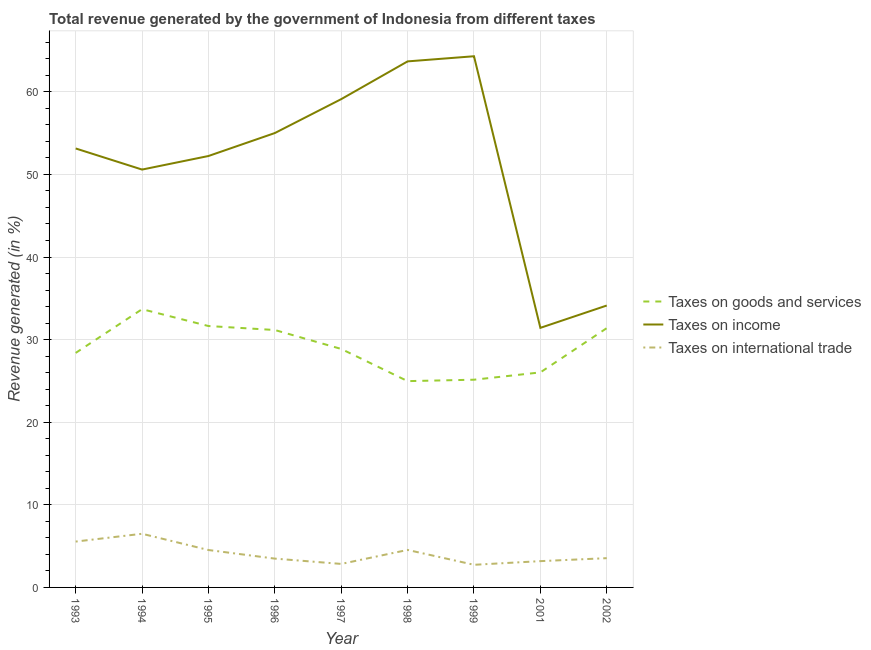How many different coloured lines are there?
Your response must be concise. 3. Does the line corresponding to percentage of revenue generated by taxes on goods and services intersect with the line corresponding to percentage of revenue generated by taxes on income?
Ensure brevity in your answer.  No. What is the percentage of revenue generated by tax on international trade in 1999?
Provide a succinct answer. 2.74. Across all years, what is the maximum percentage of revenue generated by taxes on goods and services?
Ensure brevity in your answer.  33.68. Across all years, what is the minimum percentage of revenue generated by taxes on income?
Make the answer very short. 31.42. In which year was the percentage of revenue generated by taxes on goods and services maximum?
Offer a very short reply. 1994. In which year was the percentage of revenue generated by taxes on income minimum?
Your answer should be very brief. 2001. What is the total percentage of revenue generated by taxes on goods and services in the graph?
Give a very brief answer. 261.29. What is the difference between the percentage of revenue generated by taxes on goods and services in 1993 and that in 1994?
Your answer should be very brief. -5.3. What is the difference between the percentage of revenue generated by taxes on income in 1995 and the percentage of revenue generated by tax on international trade in 2001?
Keep it short and to the point. 49.04. What is the average percentage of revenue generated by taxes on income per year?
Make the answer very short. 51.51. In the year 1995, what is the difference between the percentage of revenue generated by tax on international trade and percentage of revenue generated by taxes on income?
Ensure brevity in your answer.  -47.7. What is the ratio of the percentage of revenue generated by taxes on goods and services in 1997 to that in 1999?
Make the answer very short. 1.15. Is the percentage of revenue generated by tax on international trade in 1997 less than that in 1998?
Offer a terse response. Yes. Is the difference between the percentage of revenue generated by tax on international trade in 1993 and 1996 greater than the difference between the percentage of revenue generated by taxes on goods and services in 1993 and 1996?
Give a very brief answer. Yes. What is the difference between the highest and the second highest percentage of revenue generated by taxes on income?
Your answer should be compact. 0.62. What is the difference between the highest and the lowest percentage of revenue generated by tax on international trade?
Give a very brief answer. 3.76. In how many years, is the percentage of revenue generated by taxes on income greater than the average percentage of revenue generated by taxes on income taken over all years?
Provide a short and direct response. 6. Is the sum of the percentage of revenue generated by taxes on income in 1996 and 1998 greater than the maximum percentage of revenue generated by tax on international trade across all years?
Keep it short and to the point. Yes. Is it the case that in every year, the sum of the percentage of revenue generated by taxes on goods and services and percentage of revenue generated by taxes on income is greater than the percentage of revenue generated by tax on international trade?
Ensure brevity in your answer.  Yes. Is the percentage of revenue generated by tax on international trade strictly greater than the percentage of revenue generated by taxes on goods and services over the years?
Your answer should be compact. No. Is the percentage of revenue generated by taxes on income strictly less than the percentage of revenue generated by tax on international trade over the years?
Offer a very short reply. No. How many lines are there?
Your response must be concise. 3. What is the difference between two consecutive major ticks on the Y-axis?
Provide a short and direct response. 10. Are the values on the major ticks of Y-axis written in scientific E-notation?
Offer a very short reply. No. Does the graph contain grids?
Offer a terse response. Yes. How many legend labels are there?
Offer a terse response. 3. What is the title of the graph?
Your answer should be compact. Total revenue generated by the government of Indonesia from different taxes. Does "Self-employed" appear as one of the legend labels in the graph?
Keep it short and to the point. No. What is the label or title of the X-axis?
Make the answer very short. Year. What is the label or title of the Y-axis?
Provide a succinct answer. Revenue generated (in %). What is the Revenue generated (in %) of Taxes on goods and services in 1993?
Your answer should be compact. 28.39. What is the Revenue generated (in %) of Taxes on income in 1993?
Keep it short and to the point. 53.14. What is the Revenue generated (in %) of Taxes on international trade in 1993?
Your answer should be compact. 5.55. What is the Revenue generated (in %) of Taxes on goods and services in 1994?
Your answer should be very brief. 33.68. What is the Revenue generated (in %) in Taxes on income in 1994?
Keep it short and to the point. 50.58. What is the Revenue generated (in %) of Taxes on international trade in 1994?
Your answer should be compact. 6.5. What is the Revenue generated (in %) in Taxes on goods and services in 1995?
Give a very brief answer. 31.64. What is the Revenue generated (in %) of Taxes on income in 1995?
Keep it short and to the point. 52.23. What is the Revenue generated (in %) in Taxes on international trade in 1995?
Give a very brief answer. 4.53. What is the Revenue generated (in %) of Taxes on goods and services in 1996?
Keep it short and to the point. 31.16. What is the Revenue generated (in %) of Taxes on income in 1996?
Offer a very short reply. 55.01. What is the Revenue generated (in %) in Taxes on international trade in 1996?
Your response must be concise. 3.49. What is the Revenue generated (in %) of Taxes on goods and services in 1997?
Give a very brief answer. 28.87. What is the Revenue generated (in %) in Taxes on income in 1997?
Give a very brief answer. 59.11. What is the Revenue generated (in %) in Taxes on international trade in 1997?
Your answer should be very brief. 2.85. What is the Revenue generated (in %) of Taxes on goods and services in 1998?
Your response must be concise. 24.97. What is the Revenue generated (in %) in Taxes on income in 1998?
Your response must be concise. 63.68. What is the Revenue generated (in %) in Taxes on international trade in 1998?
Your answer should be compact. 4.54. What is the Revenue generated (in %) in Taxes on goods and services in 1999?
Provide a short and direct response. 25.14. What is the Revenue generated (in %) of Taxes on income in 1999?
Offer a very short reply. 64.3. What is the Revenue generated (in %) in Taxes on international trade in 1999?
Offer a terse response. 2.74. What is the Revenue generated (in %) in Taxes on goods and services in 2001?
Keep it short and to the point. 26.03. What is the Revenue generated (in %) of Taxes on income in 2001?
Make the answer very short. 31.42. What is the Revenue generated (in %) of Taxes on international trade in 2001?
Your answer should be very brief. 3.18. What is the Revenue generated (in %) of Taxes on goods and services in 2002?
Ensure brevity in your answer.  31.39. What is the Revenue generated (in %) of Taxes on income in 2002?
Provide a short and direct response. 34.13. What is the Revenue generated (in %) of Taxes on international trade in 2002?
Provide a succinct answer. 3.54. Across all years, what is the maximum Revenue generated (in %) of Taxes on goods and services?
Your answer should be compact. 33.68. Across all years, what is the maximum Revenue generated (in %) in Taxes on income?
Provide a short and direct response. 64.3. Across all years, what is the maximum Revenue generated (in %) in Taxes on international trade?
Provide a short and direct response. 6.5. Across all years, what is the minimum Revenue generated (in %) of Taxes on goods and services?
Offer a very short reply. 24.97. Across all years, what is the minimum Revenue generated (in %) in Taxes on income?
Provide a short and direct response. 31.42. Across all years, what is the minimum Revenue generated (in %) in Taxes on international trade?
Ensure brevity in your answer.  2.74. What is the total Revenue generated (in %) of Taxes on goods and services in the graph?
Give a very brief answer. 261.29. What is the total Revenue generated (in %) of Taxes on income in the graph?
Provide a succinct answer. 463.6. What is the total Revenue generated (in %) of Taxes on international trade in the graph?
Offer a terse response. 36.91. What is the difference between the Revenue generated (in %) of Taxes on goods and services in 1993 and that in 1994?
Offer a terse response. -5.29. What is the difference between the Revenue generated (in %) in Taxes on income in 1993 and that in 1994?
Offer a terse response. 2.55. What is the difference between the Revenue generated (in %) in Taxes on international trade in 1993 and that in 1994?
Keep it short and to the point. -0.94. What is the difference between the Revenue generated (in %) of Taxes on goods and services in 1993 and that in 1995?
Your answer should be very brief. -3.25. What is the difference between the Revenue generated (in %) in Taxes on income in 1993 and that in 1995?
Your answer should be compact. 0.91. What is the difference between the Revenue generated (in %) in Taxes on international trade in 1993 and that in 1995?
Your answer should be very brief. 1.02. What is the difference between the Revenue generated (in %) in Taxes on goods and services in 1993 and that in 1996?
Your answer should be compact. -2.77. What is the difference between the Revenue generated (in %) of Taxes on income in 1993 and that in 1996?
Offer a terse response. -1.87. What is the difference between the Revenue generated (in %) of Taxes on international trade in 1993 and that in 1996?
Give a very brief answer. 2.06. What is the difference between the Revenue generated (in %) of Taxes on goods and services in 1993 and that in 1997?
Give a very brief answer. -0.48. What is the difference between the Revenue generated (in %) in Taxes on income in 1993 and that in 1997?
Ensure brevity in your answer.  -5.97. What is the difference between the Revenue generated (in %) of Taxes on international trade in 1993 and that in 1997?
Provide a succinct answer. 2.7. What is the difference between the Revenue generated (in %) of Taxes on goods and services in 1993 and that in 1998?
Make the answer very short. 3.42. What is the difference between the Revenue generated (in %) of Taxes on income in 1993 and that in 1998?
Ensure brevity in your answer.  -10.54. What is the difference between the Revenue generated (in %) of Taxes on international trade in 1993 and that in 1998?
Keep it short and to the point. 1.01. What is the difference between the Revenue generated (in %) of Taxes on goods and services in 1993 and that in 1999?
Offer a very short reply. 3.24. What is the difference between the Revenue generated (in %) of Taxes on income in 1993 and that in 1999?
Make the answer very short. -11.16. What is the difference between the Revenue generated (in %) of Taxes on international trade in 1993 and that in 1999?
Your answer should be compact. 2.81. What is the difference between the Revenue generated (in %) of Taxes on goods and services in 1993 and that in 2001?
Offer a terse response. 2.36. What is the difference between the Revenue generated (in %) in Taxes on income in 1993 and that in 2001?
Give a very brief answer. 21.72. What is the difference between the Revenue generated (in %) of Taxes on international trade in 1993 and that in 2001?
Give a very brief answer. 2.37. What is the difference between the Revenue generated (in %) in Taxes on goods and services in 1993 and that in 2002?
Your answer should be very brief. -3. What is the difference between the Revenue generated (in %) in Taxes on income in 1993 and that in 2002?
Your response must be concise. 19.01. What is the difference between the Revenue generated (in %) in Taxes on international trade in 1993 and that in 2002?
Your answer should be very brief. 2.01. What is the difference between the Revenue generated (in %) of Taxes on goods and services in 1994 and that in 1995?
Ensure brevity in your answer.  2.04. What is the difference between the Revenue generated (in %) in Taxes on income in 1994 and that in 1995?
Your answer should be compact. -1.64. What is the difference between the Revenue generated (in %) in Taxes on international trade in 1994 and that in 1995?
Ensure brevity in your answer.  1.97. What is the difference between the Revenue generated (in %) of Taxes on goods and services in 1994 and that in 1996?
Ensure brevity in your answer.  2.52. What is the difference between the Revenue generated (in %) in Taxes on income in 1994 and that in 1996?
Your answer should be very brief. -4.42. What is the difference between the Revenue generated (in %) of Taxes on international trade in 1994 and that in 1996?
Your answer should be compact. 3.01. What is the difference between the Revenue generated (in %) in Taxes on goods and services in 1994 and that in 1997?
Offer a terse response. 4.81. What is the difference between the Revenue generated (in %) of Taxes on income in 1994 and that in 1997?
Keep it short and to the point. -8.53. What is the difference between the Revenue generated (in %) of Taxes on international trade in 1994 and that in 1997?
Make the answer very short. 3.65. What is the difference between the Revenue generated (in %) of Taxes on goods and services in 1994 and that in 1998?
Your answer should be very brief. 8.71. What is the difference between the Revenue generated (in %) of Taxes on income in 1994 and that in 1998?
Provide a succinct answer. -13.1. What is the difference between the Revenue generated (in %) in Taxes on international trade in 1994 and that in 1998?
Offer a terse response. 1.96. What is the difference between the Revenue generated (in %) in Taxes on goods and services in 1994 and that in 1999?
Make the answer very short. 8.54. What is the difference between the Revenue generated (in %) of Taxes on income in 1994 and that in 1999?
Offer a very short reply. -13.72. What is the difference between the Revenue generated (in %) in Taxes on international trade in 1994 and that in 1999?
Your answer should be very brief. 3.76. What is the difference between the Revenue generated (in %) of Taxes on goods and services in 1994 and that in 2001?
Offer a very short reply. 7.65. What is the difference between the Revenue generated (in %) in Taxes on income in 1994 and that in 2001?
Give a very brief answer. 19.16. What is the difference between the Revenue generated (in %) of Taxes on international trade in 1994 and that in 2001?
Make the answer very short. 3.31. What is the difference between the Revenue generated (in %) in Taxes on goods and services in 1994 and that in 2002?
Offer a very short reply. 2.29. What is the difference between the Revenue generated (in %) of Taxes on income in 1994 and that in 2002?
Your response must be concise. 16.46. What is the difference between the Revenue generated (in %) in Taxes on international trade in 1994 and that in 2002?
Your answer should be very brief. 2.95. What is the difference between the Revenue generated (in %) of Taxes on goods and services in 1995 and that in 1996?
Provide a succinct answer. 0.48. What is the difference between the Revenue generated (in %) of Taxes on income in 1995 and that in 1996?
Your answer should be very brief. -2.78. What is the difference between the Revenue generated (in %) of Taxes on international trade in 1995 and that in 1996?
Offer a terse response. 1.04. What is the difference between the Revenue generated (in %) of Taxes on goods and services in 1995 and that in 1997?
Make the answer very short. 2.77. What is the difference between the Revenue generated (in %) in Taxes on income in 1995 and that in 1997?
Your response must be concise. -6.89. What is the difference between the Revenue generated (in %) of Taxes on international trade in 1995 and that in 1997?
Ensure brevity in your answer.  1.68. What is the difference between the Revenue generated (in %) in Taxes on goods and services in 1995 and that in 1998?
Keep it short and to the point. 6.67. What is the difference between the Revenue generated (in %) of Taxes on income in 1995 and that in 1998?
Your answer should be very brief. -11.46. What is the difference between the Revenue generated (in %) in Taxes on international trade in 1995 and that in 1998?
Provide a succinct answer. -0.01. What is the difference between the Revenue generated (in %) of Taxes on goods and services in 1995 and that in 1999?
Make the answer very short. 6.5. What is the difference between the Revenue generated (in %) of Taxes on income in 1995 and that in 1999?
Make the answer very short. -12.08. What is the difference between the Revenue generated (in %) in Taxes on international trade in 1995 and that in 1999?
Keep it short and to the point. 1.79. What is the difference between the Revenue generated (in %) in Taxes on goods and services in 1995 and that in 2001?
Provide a short and direct response. 5.61. What is the difference between the Revenue generated (in %) of Taxes on income in 1995 and that in 2001?
Your answer should be very brief. 20.8. What is the difference between the Revenue generated (in %) of Taxes on international trade in 1995 and that in 2001?
Your answer should be compact. 1.35. What is the difference between the Revenue generated (in %) of Taxes on goods and services in 1995 and that in 2002?
Your response must be concise. 0.25. What is the difference between the Revenue generated (in %) of Taxes on income in 1995 and that in 2002?
Give a very brief answer. 18.1. What is the difference between the Revenue generated (in %) in Taxes on international trade in 1995 and that in 2002?
Your answer should be very brief. 0.99. What is the difference between the Revenue generated (in %) of Taxes on goods and services in 1996 and that in 1997?
Offer a terse response. 2.29. What is the difference between the Revenue generated (in %) in Taxes on income in 1996 and that in 1997?
Offer a terse response. -4.1. What is the difference between the Revenue generated (in %) in Taxes on international trade in 1996 and that in 1997?
Offer a very short reply. 0.64. What is the difference between the Revenue generated (in %) of Taxes on goods and services in 1996 and that in 1998?
Your answer should be compact. 6.19. What is the difference between the Revenue generated (in %) in Taxes on income in 1996 and that in 1998?
Ensure brevity in your answer.  -8.67. What is the difference between the Revenue generated (in %) of Taxes on international trade in 1996 and that in 1998?
Offer a terse response. -1.05. What is the difference between the Revenue generated (in %) in Taxes on goods and services in 1996 and that in 1999?
Provide a succinct answer. 6.02. What is the difference between the Revenue generated (in %) in Taxes on income in 1996 and that in 1999?
Provide a short and direct response. -9.3. What is the difference between the Revenue generated (in %) of Taxes on international trade in 1996 and that in 1999?
Offer a very short reply. 0.75. What is the difference between the Revenue generated (in %) in Taxes on goods and services in 1996 and that in 2001?
Your answer should be compact. 5.13. What is the difference between the Revenue generated (in %) of Taxes on income in 1996 and that in 2001?
Provide a succinct answer. 23.58. What is the difference between the Revenue generated (in %) in Taxes on international trade in 1996 and that in 2001?
Keep it short and to the point. 0.31. What is the difference between the Revenue generated (in %) of Taxes on goods and services in 1996 and that in 2002?
Provide a succinct answer. -0.23. What is the difference between the Revenue generated (in %) in Taxes on income in 1996 and that in 2002?
Provide a succinct answer. 20.88. What is the difference between the Revenue generated (in %) of Taxes on international trade in 1996 and that in 2002?
Give a very brief answer. -0.05. What is the difference between the Revenue generated (in %) of Taxes on goods and services in 1997 and that in 1998?
Offer a very short reply. 3.9. What is the difference between the Revenue generated (in %) of Taxes on income in 1997 and that in 1998?
Keep it short and to the point. -4.57. What is the difference between the Revenue generated (in %) of Taxes on international trade in 1997 and that in 1998?
Keep it short and to the point. -1.69. What is the difference between the Revenue generated (in %) of Taxes on goods and services in 1997 and that in 1999?
Your response must be concise. 3.72. What is the difference between the Revenue generated (in %) of Taxes on income in 1997 and that in 1999?
Your answer should be very brief. -5.19. What is the difference between the Revenue generated (in %) in Taxes on international trade in 1997 and that in 1999?
Keep it short and to the point. 0.11. What is the difference between the Revenue generated (in %) in Taxes on goods and services in 1997 and that in 2001?
Provide a short and direct response. 2.84. What is the difference between the Revenue generated (in %) of Taxes on income in 1997 and that in 2001?
Provide a short and direct response. 27.69. What is the difference between the Revenue generated (in %) of Taxes on international trade in 1997 and that in 2001?
Offer a very short reply. -0.34. What is the difference between the Revenue generated (in %) in Taxes on goods and services in 1997 and that in 2002?
Provide a short and direct response. -2.52. What is the difference between the Revenue generated (in %) in Taxes on income in 1997 and that in 2002?
Offer a terse response. 24.98. What is the difference between the Revenue generated (in %) in Taxes on international trade in 1997 and that in 2002?
Your answer should be compact. -0.7. What is the difference between the Revenue generated (in %) of Taxes on goods and services in 1998 and that in 1999?
Give a very brief answer. -0.17. What is the difference between the Revenue generated (in %) in Taxes on income in 1998 and that in 1999?
Your answer should be compact. -0.62. What is the difference between the Revenue generated (in %) in Taxes on international trade in 1998 and that in 1999?
Provide a short and direct response. 1.8. What is the difference between the Revenue generated (in %) of Taxes on goods and services in 1998 and that in 2001?
Your answer should be very brief. -1.06. What is the difference between the Revenue generated (in %) of Taxes on income in 1998 and that in 2001?
Ensure brevity in your answer.  32.26. What is the difference between the Revenue generated (in %) in Taxes on international trade in 1998 and that in 2001?
Your answer should be very brief. 1.36. What is the difference between the Revenue generated (in %) of Taxes on goods and services in 1998 and that in 2002?
Give a very brief answer. -6.42. What is the difference between the Revenue generated (in %) of Taxes on income in 1998 and that in 2002?
Your answer should be very brief. 29.55. What is the difference between the Revenue generated (in %) in Taxes on international trade in 1998 and that in 2002?
Provide a short and direct response. 1. What is the difference between the Revenue generated (in %) of Taxes on goods and services in 1999 and that in 2001?
Provide a succinct answer. -0.89. What is the difference between the Revenue generated (in %) in Taxes on income in 1999 and that in 2001?
Ensure brevity in your answer.  32.88. What is the difference between the Revenue generated (in %) in Taxes on international trade in 1999 and that in 2001?
Provide a short and direct response. -0.44. What is the difference between the Revenue generated (in %) of Taxes on goods and services in 1999 and that in 2002?
Keep it short and to the point. -6.25. What is the difference between the Revenue generated (in %) in Taxes on income in 1999 and that in 2002?
Make the answer very short. 30.18. What is the difference between the Revenue generated (in %) in Taxes on international trade in 1999 and that in 2002?
Offer a terse response. -0.8. What is the difference between the Revenue generated (in %) of Taxes on goods and services in 2001 and that in 2002?
Ensure brevity in your answer.  -5.36. What is the difference between the Revenue generated (in %) in Taxes on income in 2001 and that in 2002?
Give a very brief answer. -2.7. What is the difference between the Revenue generated (in %) of Taxes on international trade in 2001 and that in 2002?
Your answer should be very brief. -0.36. What is the difference between the Revenue generated (in %) in Taxes on goods and services in 1993 and the Revenue generated (in %) in Taxes on income in 1994?
Your answer should be compact. -22.19. What is the difference between the Revenue generated (in %) in Taxes on goods and services in 1993 and the Revenue generated (in %) in Taxes on international trade in 1994?
Provide a short and direct response. 21.89. What is the difference between the Revenue generated (in %) of Taxes on income in 1993 and the Revenue generated (in %) of Taxes on international trade in 1994?
Your response must be concise. 46.64. What is the difference between the Revenue generated (in %) of Taxes on goods and services in 1993 and the Revenue generated (in %) of Taxes on income in 1995?
Your response must be concise. -23.84. What is the difference between the Revenue generated (in %) of Taxes on goods and services in 1993 and the Revenue generated (in %) of Taxes on international trade in 1995?
Make the answer very short. 23.86. What is the difference between the Revenue generated (in %) in Taxes on income in 1993 and the Revenue generated (in %) in Taxes on international trade in 1995?
Ensure brevity in your answer.  48.61. What is the difference between the Revenue generated (in %) of Taxes on goods and services in 1993 and the Revenue generated (in %) of Taxes on income in 1996?
Your response must be concise. -26.62. What is the difference between the Revenue generated (in %) in Taxes on goods and services in 1993 and the Revenue generated (in %) in Taxes on international trade in 1996?
Offer a very short reply. 24.9. What is the difference between the Revenue generated (in %) of Taxes on income in 1993 and the Revenue generated (in %) of Taxes on international trade in 1996?
Make the answer very short. 49.65. What is the difference between the Revenue generated (in %) in Taxes on goods and services in 1993 and the Revenue generated (in %) in Taxes on income in 1997?
Your answer should be very brief. -30.72. What is the difference between the Revenue generated (in %) of Taxes on goods and services in 1993 and the Revenue generated (in %) of Taxes on international trade in 1997?
Ensure brevity in your answer.  25.54. What is the difference between the Revenue generated (in %) of Taxes on income in 1993 and the Revenue generated (in %) of Taxes on international trade in 1997?
Your response must be concise. 50.29. What is the difference between the Revenue generated (in %) of Taxes on goods and services in 1993 and the Revenue generated (in %) of Taxes on income in 1998?
Provide a short and direct response. -35.29. What is the difference between the Revenue generated (in %) in Taxes on goods and services in 1993 and the Revenue generated (in %) in Taxes on international trade in 1998?
Your answer should be compact. 23.85. What is the difference between the Revenue generated (in %) in Taxes on income in 1993 and the Revenue generated (in %) in Taxes on international trade in 1998?
Your answer should be compact. 48.6. What is the difference between the Revenue generated (in %) of Taxes on goods and services in 1993 and the Revenue generated (in %) of Taxes on income in 1999?
Offer a very short reply. -35.91. What is the difference between the Revenue generated (in %) of Taxes on goods and services in 1993 and the Revenue generated (in %) of Taxes on international trade in 1999?
Provide a succinct answer. 25.65. What is the difference between the Revenue generated (in %) in Taxes on income in 1993 and the Revenue generated (in %) in Taxes on international trade in 1999?
Offer a terse response. 50.4. What is the difference between the Revenue generated (in %) of Taxes on goods and services in 1993 and the Revenue generated (in %) of Taxes on income in 2001?
Your answer should be very brief. -3.03. What is the difference between the Revenue generated (in %) in Taxes on goods and services in 1993 and the Revenue generated (in %) in Taxes on international trade in 2001?
Ensure brevity in your answer.  25.21. What is the difference between the Revenue generated (in %) in Taxes on income in 1993 and the Revenue generated (in %) in Taxes on international trade in 2001?
Keep it short and to the point. 49.96. What is the difference between the Revenue generated (in %) in Taxes on goods and services in 1993 and the Revenue generated (in %) in Taxes on income in 2002?
Make the answer very short. -5.74. What is the difference between the Revenue generated (in %) in Taxes on goods and services in 1993 and the Revenue generated (in %) in Taxes on international trade in 2002?
Provide a short and direct response. 24.85. What is the difference between the Revenue generated (in %) of Taxes on income in 1993 and the Revenue generated (in %) of Taxes on international trade in 2002?
Your response must be concise. 49.6. What is the difference between the Revenue generated (in %) in Taxes on goods and services in 1994 and the Revenue generated (in %) in Taxes on income in 1995?
Your answer should be compact. -18.54. What is the difference between the Revenue generated (in %) of Taxes on goods and services in 1994 and the Revenue generated (in %) of Taxes on international trade in 1995?
Offer a terse response. 29.16. What is the difference between the Revenue generated (in %) in Taxes on income in 1994 and the Revenue generated (in %) in Taxes on international trade in 1995?
Your answer should be very brief. 46.06. What is the difference between the Revenue generated (in %) in Taxes on goods and services in 1994 and the Revenue generated (in %) in Taxes on income in 1996?
Provide a short and direct response. -21.32. What is the difference between the Revenue generated (in %) of Taxes on goods and services in 1994 and the Revenue generated (in %) of Taxes on international trade in 1996?
Offer a terse response. 30.2. What is the difference between the Revenue generated (in %) of Taxes on income in 1994 and the Revenue generated (in %) of Taxes on international trade in 1996?
Keep it short and to the point. 47.1. What is the difference between the Revenue generated (in %) in Taxes on goods and services in 1994 and the Revenue generated (in %) in Taxes on income in 1997?
Provide a short and direct response. -25.43. What is the difference between the Revenue generated (in %) in Taxes on goods and services in 1994 and the Revenue generated (in %) in Taxes on international trade in 1997?
Make the answer very short. 30.84. What is the difference between the Revenue generated (in %) of Taxes on income in 1994 and the Revenue generated (in %) of Taxes on international trade in 1997?
Give a very brief answer. 47.74. What is the difference between the Revenue generated (in %) of Taxes on goods and services in 1994 and the Revenue generated (in %) of Taxes on income in 1998?
Keep it short and to the point. -30. What is the difference between the Revenue generated (in %) in Taxes on goods and services in 1994 and the Revenue generated (in %) in Taxes on international trade in 1998?
Give a very brief answer. 29.15. What is the difference between the Revenue generated (in %) in Taxes on income in 1994 and the Revenue generated (in %) in Taxes on international trade in 1998?
Make the answer very short. 46.05. What is the difference between the Revenue generated (in %) of Taxes on goods and services in 1994 and the Revenue generated (in %) of Taxes on income in 1999?
Offer a very short reply. -30.62. What is the difference between the Revenue generated (in %) of Taxes on goods and services in 1994 and the Revenue generated (in %) of Taxes on international trade in 1999?
Give a very brief answer. 30.94. What is the difference between the Revenue generated (in %) in Taxes on income in 1994 and the Revenue generated (in %) in Taxes on international trade in 1999?
Ensure brevity in your answer.  47.84. What is the difference between the Revenue generated (in %) of Taxes on goods and services in 1994 and the Revenue generated (in %) of Taxes on income in 2001?
Keep it short and to the point. 2.26. What is the difference between the Revenue generated (in %) of Taxes on goods and services in 1994 and the Revenue generated (in %) of Taxes on international trade in 2001?
Your answer should be very brief. 30.5. What is the difference between the Revenue generated (in %) of Taxes on income in 1994 and the Revenue generated (in %) of Taxes on international trade in 2001?
Make the answer very short. 47.4. What is the difference between the Revenue generated (in %) in Taxes on goods and services in 1994 and the Revenue generated (in %) in Taxes on income in 2002?
Your response must be concise. -0.44. What is the difference between the Revenue generated (in %) in Taxes on goods and services in 1994 and the Revenue generated (in %) in Taxes on international trade in 2002?
Keep it short and to the point. 30.14. What is the difference between the Revenue generated (in %) of Taxes on income in 1994 and the Revenue generated (in %) of Taxes on international trade in 2002?
Provide a succinct answer. 47.04. What is the difference between the Revenue generated (in %) of Taxes on goods and services in 1995 and the Revenue generated (in %) of Taxes on income in 1996?
Your answer should be very brief. -23.36. What is the difference between the Revenue generated (in %) in Taxes on goods and services in 1995 and the Revenue generated (in %) in Taxes on international trade in 1996?
Make the answer very short. 28.16. What is the difference between the Revenue generated (in %) in Taxes on income in 1995 and the Revenue generated (in %) in Taxes on international trade in 1996?
Offer a very short reply. 48.74. What is the difference between the Revenue generated (in %) in Taxes on goods and services in 1995 and the Revenue generated (in %) in Taxes on income in 1997?
Make the answer very short. -27.47. What is the difference between the Revenue generated (in %) in Taxes on goods and services in 1995 and the Revenue generated (in %) in Taxes on international trade in 1997?
Give a very brief answer. 28.8. What is the difference between the Revenue generated (in %) of Taxes on income in 1995 and the Revenue generated (in %) of Taxes on international trade in 1997?
Ensure brevity in your answer.  49.38. What is the difference between the Revenue generated (in %) of Taxes on goods and services in 1995 and the Revenue generated (in %) of Taxes on income in 1998?
Your answer should be compact. -32.04. What is the difference between the Revenue generated (in %) in Taxes on goods and services in 1995 and the Revenue generated (in %) in Taxes on international trade in 1998?
Ensure brevity in your answer.  27.11. What is the difference between the Revenue generated (in %) in Taxes on income in 1995 and the Revenue generated (in %) in Taxes on international trade in 1998?
Keep it short and to the point. 47.69. What is the difference between the Revenue generated (in %) in Taxes on goods and services in 1995 and the Revenue generated (in %) in Taxes on income in 1999?
Your answer should be very brief. -32.66. What is the difference between the Revenue generated (in %) in Taxes on goods and services in 1995 and the Revenue generated (in %) in Taxes on international trade in 1999?
Offer a terse response. 28.9. What is the difference between the Revenue generated (in %) in Taxes on income in 1995 and the Revenue generated (in %) in Taxes on international trade in 1999?
Give a very brief answer. 49.49. What is the difference between the Revenue generated (in %) of Taxes on goods and services in 1995 and the Revenue generated (in %) of Taxes on income in 2001?
Make the answer very short. 0.22. What is the difference between the Revenue generated (in %) in Taxes on goods and services in 1995 and the Revenue generated (in %) in Taxes on international trade in 2001?
Offer a very short reply. 28.46. What is the difference between the Revenue generated (in %) of Taxes on income in 1995 and the Revenue generated (in %) of Taxes on international trade in 2001?
Keep it short and to the point. 49.04. What is the difference between the Revenue generated (in %) in Taxes on goods and services in 1995 and the Revenue generated (in %) in Taxes on income in 2002?
Give a very brief answer. -2.48. What is the difference between the Revenue generated (in %) in Taxes on goods and services in 1995 and the Revenue generated (in %) in Taxes on international trade in 2002?
Offer a very short reply. 28.1. What is the difference between the Revenue generated (in %) in Taxes on income in 1995 and the Revenue generated (in %) in Taxes on international trade in 2002?
Make the answer very short. 48.68. What is the difference between the Revenue generated (in %) of Taxes on goods and services in 1996 and the Revenue generated (in %) of Taxes on income in 1997?
Your answer should be compact. -27.95. What is the difference between the Revenue generated (in %) in Taxes on goods and services in 1996 and the Revenue generated (in %) in Taxes on international trade in 1997?
Provide a short and direct response. 28.32. What is the difference between the Revenue generated (in %) in Taxes on income in 1996 and the Revenue generated (in %) in Taxes on international trade in 1997?
Make the answer very short. 52.16. What is the difference between the Revenue generated (in %) of Taxes on goods and services in 1996 and the Revenue generated (in %) of Taxes on income in 1998?
Offer a terse response. -32.52. What is the difference between the Revenue generated (in %) of Taxes on goods and services in 1996 and the Revenue generated (in %) of Taxes on international trade in 1998?
Ensure brevity in your answer.  26.62. What is the difference between the Revenue generated (in %) in Taxes on income in 1996 and the Revenue generated (in %) in Taxes on international trade in 1998?
Your answer should be compact. 50.47. What is the difference between the Revenue generated (in %) in Taxes on goods and services in 1996 and the Revenue generated (in %) in Taxes on income in 1999?
Keep it short and to the point. -33.14. What is the difference between the Revenue generated (in %) of Taxes on goods and services in 1996 and the Revenue generated (in %) of Taxes on international trade in 1999?
Make the answer very short. 28.42. What is the difference between the Revenue generated (in %) in Taxes on income in 1996 and the Revenue generated (in %) in Taxes on international trade in 1999?
Ensure brevity in your answer.  52.27. What is the difference between the Revenue generated (in %) of Taxes on goods and services in 1996 and the Revenue generated (in %) of Taxes on income in 2001?
Ensure brevity in your answer.  -0.26. What is the difference between the Revenue generated (in %) in Taxes on goods and services in 1996 and the Revenue generated (in %) in Taxes on international trade in 2001?
Give a very brief answer. 27.98. What is the difference between the Revenue generated (in %) of Taxes on income in 1996 and the Revenue generated (in %) of Taxes on international trade in 2001?
Offer a very short reply. 51.82. What is the difference between the Revenue generated (in %) in Taxes on goods and services in 1996 and the Revenue generated (in %) in Taxes on income in 2002?
Your answer should be very brief. -2.96. What is the difference between the Revenue generated (in %) in Taxes on goods and services in 1996 and the Revenue generated (in %) in Taxes on international trade in 2002?
Offer a very short reply. 27.62. What is the difference between the Revenue generated (in %) in Taxes on income in 1996 and the Revenue generated (in %) in Taxes on international trade in 2002?
Provide a short and direct response. 51.46. What is the difference between the Revenue generated (in %) of Taxes on goods and services in 1997 and the Revenue generated (in %) of Taxes on income in 1998?
Your answer should be very brief. -34.81. What is the difference between the Revenue generated (in %) of Taxes on goods and services in 1997 and the Revenue generated (in %) of Taxes on international trade in 1998?
Your answer should be very brief. 24.33. What is the difference between the Revenue generated (in %) of Taxes on income in 1997 and the Revenue generated (in %) of Taxes on international trade in 1998?
Make the answer very short. 54.57. What is the difference between the Revenue generated (in %) of Taxes on goods and services in 1997 and the Revenue generated (in %) of Taxes on income in 1999?
Offer a terse response. -35.43. What is the difference between the Revenue generated (in %) in Taxes on goods and services in 1997 and the Revenue generated (in %) in Taxes on international trade in 1999?
Make the answer very short. 26.13. What is the difference between the Revenue generated (in %) of Taxes on income in 1997 and the Revenue generated (in %) of Taxes on international trade in 1999?
Your response must be concise. 56.37. What is the difference between the Revenue generated (in %) in Taxes on goods and services in 1997 and the Revenue generated (in %) in Taxes on income in 2001?
Provide a succinct answer. -2.55. What is the difference between the Revenue generated (in %) in Taxes on goods and services in 1997 and the Revenue generated (in %) in Taxes on international trade in 2001?
Your response must be concise. 25.69. What is the difference between the Revenue generated (in %) in Taxes on income in 1997 and the Revenue generated (in %) in Taxes on international trade in 2001?
Give a very brief answer. 55.93. What is the difference between the Revenue generated (in %) of Taxes on goods and services in 1997 and the Revenue generated (in %) of Taxes on income in 2002?
Your answer should be compact. -5.26. What is the difference between the Revenue generated (in %) of Taxes on goods and services in 1997 and the Revenue generated (in %) of Taxes on international trade in 2002?
Provide a succinct answer. 25.33. What is the difference between the Revenue generated (in %) of Taxes on income in 1997 and the Revenue generated (in %) of Taxes on international trade in 2002?
Ensure brevity in your answer.  55.57. What is the difference between the Revenue generated (in %) of Taxes on goods and services in 1998 and the Revenue generated (in %) of Taxes on income in 1999?
Your answer should be very brief. -39.33. What is the difference between the Revenue generated (in %) of Taxes on goods and services in 1998 and the Revenue generated (in %) of Taxes on international trade in 1999?
Keep it short and to the point. 22.23. What is the difference between the Revenue generated (in %) of Taxes on income in 1998 and the Revenue generated (in %) of Taxes on international trade in 1999?
Make the answer very short. 60.94. What is the difference between the Revenue generated (in %) of Taxes on goods and services in 1998 and the Revenue generated (in %) of Taxes on income in 2001?
Ensure brevity in your answer.  -6.45. What is the difference between the Revenue generated (in %) of Taxes on goods and services in 1998 and the Revenue generated (in %) of Taxes on international trade in 2001?
Your answer should be very brief. 21.79. What is the difference between the Revenue generated (in %) in Taxes on income in 1998 and the Revenue generated (in %) in Taxes on international trade in 2001?
Keep it short and to the point. 60.5. What is the difference between the Revenue generated (in %) of Taxes on goods and services in 1998 and the Revenue generated (in %) of Taxes on income in 2002?
Provide a succinct answer. -9.15. What is the difference between the Revenue generated (in %) in Taxes on goods and services in 1998 and the Revenue generated (in %) in Taxes on international trade in 2002?
Provide a succinct answer. 21.43. What is the difference between the Revenue generated (in %) in Taxes on income in 1998 and the Revenue generated (in %) in Taxes on international trade in 2002?
Offer a terse response. 60.14. What is the difference between the Revenue generated (in %) in Taxes on goods and services in 1999 and the Revenue generated (in %) in Taxes on income in 2001?
Make the answer very short. -6.28. What is the difference between the Revenue generated (in %) in Taxes on goods and services in 1999 and the Revenue generated (in %) in Taxes on international trade in 2001?
Provide a succinct answer. 21.96. What is the difference between the Revenue generated (in %) of Taxes on income in 1999 and the Revenue generated (in %) of Taxes on international trade in 2001?
Make the answer very short. 61.12. What is the difference between the Revenue generated (in %) in Taxes on goods and services in 1999 and the Revenue generated (in %) in Taxes on income in 2002?
Your answer should be compact. -8.98. What is the difference between the Revenue generated (in %) of Taxes on goods and services in 1999 and the Revenue generated (in %) of Taxes on international trade in 2002?
Keep it short and to the point. 21.6. What is the difference between the Revenue generated (in %) in Taxes on income in 1999 and the Revenue generated (in %) in Taxes on international trade in 2002?
Provide a succinct answer. 60.76. What is the difference between the Revenue generated (in %) of Taxes on goods and services in 2001 and the Revenue generated (in %) of Taxes on income in 2002?
Provide a succinct answer. -8.1. What is the difference between the Revenue generated (in %) in Taxes on goods and services in 2001 and the Revenue generated (in %) in Taxes on international trade in 2002?
Provide a short and direct response. 22.49. What is the difference between the Revenue generated (in %) in Taxes on income in 2001 and the Revenue generated (in %) in Taxes on international trade in 2002?
Ensure brevity in your answer.  27.88. What is the average Revenue generated (in %) in Taxes on goods and services per year?
Offer a very short reply. 29.03. What is the average Revenue generated (in %) in Taxes on income per year?
Give a very brief answer. 51.51. What is the average Revenue generated (in %) in Taxes on international trade per year?
Offer a very short reply. 4.1. In the year 1993, what is the difference between the Revenue generated (in %) of Taxes on goods and services and Revenue generated (in %) of Taxes on income?
Ensure brevity in your answer.  -24.75. In the year 1993, what is the difference between the Revenue generated (in %) of Taxes on goods and services and Revenue generated (in %) of Taxes on international trade?
Ensure brevity in your answer.  22.84. In the year 1993, what is the difference between the Revenue generated (in %) in Taxes on income and Revenue generated (in %) in Taxes on international trade?
Make the answer very short. 47.59. In the year 1994, what is the difference between the Revenue generated (in %) of Taxes on goods and services and Revenue generated (in %) of Taxes on income?
Offer a terse response. -16.9. In the year 1994, what is the difference between the Revenue generated (in %) in Taxes on goods and services and Revenue generated (in %) in Taxes on international trade?
Your answer should be compact. 27.19. In the year 1994, what is the difference between the Revenue generated (in %) of Taxes on income and Revenue generated (in %) of Taxes on international trade?
Provide a short and direct response. 44.09. In the year 1995, what is the difference between the Revenue generated (in %) of Taxes on goods and services and Revenue generated (in %) of Taxes on income?
Provide a succinct answer. -20.58. In the year 1995, what is the difference between the Revenue generated (in %) of Taxes on goods and services and Revenue generated (in %) of Taxes on international trade?
Provide a succinct answer. 27.12. In the year 1995, what is the difference between the Revenue generated (in %) of Taxes on income and Revenue generated (in %) of Taxes on international trade?
Your answer should be very brief. 47.7. In the year 1996, what is the difference between the Revenue generated (in %) in Taxes on goods and services and Revenue generated (in %) in Taxes on income?
Provide a short and direct response. -23.84. In the year 1996, what is the difference between the Revenue generated (in %) in Taxes on goods and services and Revenue generated (in %) in Taxes on international trade?
Offer a terse response. 27.67. In the year 1996, what is the difference between the Revenue generated (in %) in Taxes on income and Revenue generated (in %) in Taxes on international trade?
Keep it short and to the point. 51.52. In the year 1997, what is the difference between the Revenue generated (in %) in Taxes on goods and services and Revenue generated (in %) in Taxes on income?
Make the answer very short. -30.24. In the year 1997, what is the difference between the Revenue generated (in %) of Taxes on goods and services and Revenue generated (in %) of Taxes on international trade?
Offer a terse response. 26.02. In the year 1997, what is the difference between the Revenue generated (in %) in Taxes on income and Revenue generated (in %) in Taxes on international trade?
Keep it short and to the point. 56.26. In the year 1998, what is the difference between the Revenue generated (in %) in Taxes on goods and services and Revenue generated (in %) in Taxes on income?
Provide a succinct answer. -38.71. In the year 1998, what is the difference between the Revenue generated (in %) in Taxes on goods and services and Revenue generated (in %) in Taxes on international trade?
Your answer should be compact. 20.43. In the year 1998, what is the difference between the Revenue generated (in %) in Taxes on income and Revenue generated (in %) in Taxes on international trade?
Give a very brief answer. 59.14. In the year 1999, what is the difference between the Revenue generated (in %) of Taxes on goods and services and Revenue generated (in %) of Taxes on income?
Your answer should be very brief. -39.16. In the year 1999, what is the difference between the Revenue generated (in %) in Taxes on goods and services and Revenue generated (in %) in Taxes on international trade?
Offer a terse response. 22.4. In the year 1999, what is the difference between the Revenue generated (in %) of Taxes on income and Revenue generated (in %) of Taxes on international trade?
Provide a succinct answer. 61.56. In the year 2001, what is the difference between the Revenue generated (in %) of Taxes on goods and services and Revenue generated (in %) of Taxes on income?
Offer a very short reply. -5.39. In the year 2001, what is the difference between the Revenue generated (in %) of Taxes on goods and services and Revenue generated (in %) of Taxes on international trade?
Your response must be concise. 22.85. In the year 2001, what is the difference between the Revenue generated (in %) of Taxes on income and Revenue generated (in %) of Taxes on international trade?
Offer a terse response. 28.24. In the year 2002, what is the difference between the Revenue generated (in %) of Taxes on goods and services and Revenue generated (in %) of Taxes on income?
Provide a succinct answer. -2.74. In the year 2002, what is the difference between the Revenue generated (in %) in Taxes on goods and services and Revenue generated (in %) in Taxes on international trade?
Your answer should be compact. 27.85. In the year 2002, what is the difference between the Revenue generated (in %) of Taxes on income and Revenue generated (in %) of Taxes on international trade?
Offer a terse response. 30.58. What is the ratio of the Revenue generated (in %) of Taxes on goods and services in 1993 to that in 1994?
Provide a short and direct response. 0.84. What is the ratio of the Revenue generated (in %) of Taxes on income in 1993 to that in 1994?
Give a very brief answer. 1.05. What is the ratio of the Revenue generated (in %) of Taxes on international trade in 1993 to that in 1994?
Offer a terse response. 0.85. What is the ratio of the Revenue generated (in %) of Taxes on goods and services in 1993 to that in 1995?
Keep it short and to the point. 0.9. What is the ratio of the Revenue generated (in %) of Taxes on income in 1993 to that in 1995?
Your response must be concise. 1.02. What is the ratio of the Revenue generated (in %) of Taxes on international trade in 1993 to that in 1995?
Offer a very short reply. 1.23. What is the ratio of the Revenue generated (in %) in Taxes on goods and services in 1993 to that in 1996?
Offer a terse response. 0.91. What is the ratio of the Revenue generated (in %) in Taxes on income in 1993 to that in 1996?
Make the answer very short. 0.97. What is the ratio of the Revenue generated (in %) in Taxes on international trade in 1993 to that in 1996?
Offer a terse response. 1.59. What is the ratio of the Revenue generated (in %) of Taxes on goods and services in 1993 to that in 1997?
Your answer should be very brief. 0.98. What is the ratio of the Revenue generated (in %) of Taxes on income in 1993 to that in 1997?
Your response must be concise. 0.9. What is the ratio of the Revenue generated (in %) of Taxes on international trade in 1993 to that in 1997?
Offer a very short reply. 1.95. What is the ratio of the Revenue generated (in %) in Taxes on goods and services in 1993 to that in 1998?
Your answer should be very brief. 1.14. What is the ratio of the Revenue generated (in %) of Taxes on income in 1993 to that in 1998?
Make the answer very short. 0.83. What is the ratio of the Revenue generated (in %) of Taxes on international trade in 1993 to that in 1998?
Your answer should be very brief. 1.22. What is the ratio of the Revenue generated (in %) in Taxes on goods and services in 1993 to that in 1999?
Offer a very short reply. 1.13. What is the ratio of the Revenue generated (in %) in Taxes on income in 1993 to that in 1999?
Your response must be concise. 0.83. What is the ratio of the Revenue generated (in %) in Taxes on international trade in 1993 to that in 1999?
Your response must be concise. 2.03. What is the ratio of the Revenue generated (in %) of Taxes on goods and services in 1993 to that in 2001?
Offer a very short reply. 1.09. What is the ratio of the Revenue generated (in %) in Taxes on income in 1993 to that in 2001?
Provide a succinct answer. 1.69. What is the ratio of the Revenue generated (in %) in Taxes on international trade in 1993 to that in 2001?
Make the answer very short. 1.74. What is the ratio of the Revenue generated (in %) in Taxes on goods and services in 1993 to that in 2002?
Your answer should be very brief. 0.9. What is the ratio of the Revenue generated (in %) of Taxes on income in 1993 to that in 2002?
Keep it short and to the point. 1.56. What is the ratio of the Revenue generated (in %) of Taxes on international trade in 1993 to that in 2002?
Ensure brevity in your answer.  1.57. What is the ratio of the Revenue generated (in %) of Taxes on goods and services in 1994 to that in 1995?
Ensure brevity in your answer.  1.06. What is the ratio of the Revenue generated (in %) of Taxes on income in 1994 to that in 1995?
Offer a terse response. 0.97. What is the ratio of the Revenue generated (in %) in Taxes on international trade in 1994 to that in 1995?
Offer a very short reply. 1.43. What is the ratio of the Revenue generated (in %) in Taxes on goods and services in 1994 to that in 1996?
Provide a succinct answer. 1.08. What is the ratio of the Revenue generated (in %) of Taxes on income in 1994 to that in 1996?
Your answer should be very brief. 0.92. What is the ratio of the Revenue generated (in %) in Taxes on international trade in 1994 to that in 1996?
Provide a short and direct response. 1.86. What is the ratio of the Revenue generated (in %) in Taxes on goods and services in 1994 to that in 1997?
Offer a terse response. 1.17. What is the ratio of the Revenue generated (in %) of Taxes on income in 1994 to that in 1997?
Provide a short and direct response. 0.86. What is the ratio of the Revenue generated (in %) in Taxes on international trade in 1994 to that in 1997?
Your response must be concise. 2.28. What is the ratio of the Revenue generated (in %) in Taxes on goods and services in 1994 to that in 1998?
Provide a short and direct response. 1.35. What is the ratio of the Revenue generated (in %) in Taxes on income in 1994 to that in 1998?
Your response must be concise. 0.79. What is the ratio of the Revenue generated (in %) of Taxes on international trade in 1994 to that in 1998?
Your answer should be very brief. 1.43. What is the ratio of the Revenue generated (in %) of Taxes on goods and services in 1994 to that in 1999?
Offer a very short reply. 1.34. What is the ratio of the Revenue generated (in %) in Taxes on income in 1994 to that in 1999?
Offer a terse response. 0.79. What is the ratio of the Revenue generated (in %) in Taxes on international trade in 1994 to that in 1999?
Your answer should be compact. 2.37. What is the ratio of the Revenue generated (in %) in Taxes on goods and services in 1994 to that in 2001?
Provide a succinct answer. 1.29. What is the ratio of the Revenue generated (in %) in Taxes on income in 1994 to that in 2001?
Your answer should be very brief. 1.61. What is the ratio of the Revenue generated (in %) in Taxes on international trade in 1994 to that in 2001?
Offer a very short reply. 2.04. What is the ratio of the Revenue generated (in %) in Taxes on goods and services in 1994 to that in 2002?
Provide a succinct answer. 1.07. What is the ratio of the Revenue generated (in %) in Taxes on income in 1994 to that in 2002?
Provide a short and direct response. 1.48. What is the ratio of the Revenue generated (in %) of Taxes on international trade in 1994 to that in 2002?
Provide a succinct answer. 1.83. What is the ratio of the Revenue generated (in %) in Taxes on goods and services in 1995 to that in 1996?
Give a very brief answer. 1.02. What is the ratio of the Revenue generated (in %) of Taxes on income in 1995 to that in 1996?
Offer a very short reply. 0.95. What is the ratio of the Revenue generated (in %) in Taxes on international trade in 1995 to that in 1996?
Your answer should be compact. 1.3. What is the ratio of the Revenue generated (in %) of Taxes on goods and services in 1995 to that in 1997?
Offer a terse response. 1.1. What is the ratio of the Revenue generated (in %) of Taxes on income in 1995 to that in 1997?
Your answer should be compact. 0.88. What is the ratio of the Revenue generated (in %) in Taxes on international trade in 1995 to that in 1997?
Ensure brevity in your answer.  1.59. What is the ratio of the Revenue generated (in %) of Taxes on goods and services in 1995 to that in 1998?
Keep it short and to the point. 1.27. What is the ratio of the Revenue generated (in %) of Taxes on income in 1995 to that in 1998?
Offer a terse response. 0.82. What is the ratio of the Revenue generated (in %) of Taxes on goods and services in 1995 to that in 1999?
Keep it short and to the point. 1.26. What is the ratio of the Revenue generated (in %) in Taxes on income in 1995 to that in 1999?
Ensure brevity in your answer.  0.81. What is the ratio of the Revenue generated (in %) in Taxes on international trade in 1995 to that in 1999?
Keep it short and to the point. 1.65. What is the ratio of the Revenue generated (in %) in Taxes on goods and services in 1995 to that in 2001?
Offer a terse response. 1.22. What is the ratio of the Revenue generated (in %) of Taxes on income in 1995 to that in 2001?
Offer a very short reply. 1.66. What is the ratio of the Revenue generated (in %) of Taxes on international trade in 1995 to that in 2001?
Give a very brief answer. 1.42. What is the ratio of the Revenue generated (in %) in Taxes on goods and services in 1995 to that in 2002?
Offer a terse response. 1.01. What is the ratio of the Revenue generated (in %) of Taxes on income in 1995 to that in 2002?
Make the answer very short. 1.53. What is the ratio of the Revenue generated (in %) in Taxes on international trade in 1995 to that in 2002?
Provide a succinct answer. 1.28. What is the ratio of the Revenue generated (in %) in Taxes on goods and services in 1996 to that in 1997?
Your response must be concise. 1.08. What is the ratio of the Revenue generated (in %) in Taxes on income in 1996 to that in 1997?
Provide a succinct answer. 0.93. What is the ratio of the Revenue generated (in %) of Taxes on international trade in 1996 to that in 1997?
Keep it short and to the point. 1.23. What is the ratio of the Revenue generated (in %) of Taxes on goods and services in 1996 to that in 1998?
Provide a short and direct response. 1.25. What is the ratio of the Revenue generated (in %) of Taxes on income in 1996 to that in 1998?
Make the answer very short. 0.86. What is the ratio of the Revenue generated (in %) in Taxes on international trade in 1996 to that in 1998?
Your answer should be very brief. 0.77. What is the ratio of the Revenue generated (in %) of Taxes on goods and services in 1996 to that in 1999?
Your answer should be compact. 1.24. What is the ratio of the Revenue generated (in %) in Taxes on income in 1996 to that in 1999?
Your response must be concise. 0.86. What is the ratio of the Revenue generated (in %) of Taxes on international trade in 1996 to that in 1999?
Give a very brief answer. 1.27. What is the ratio of the Revenue generated (in %) of Taxes on goods and services in 1996 to that in 2001?
Ensure brevity in your answer.  1.2. What is the ratio of the Revenue generated (in %) of Taxes on income in 1996 to that in 2001?
Ensure brevity in your answer.  1.75. What is the ratio of the Revenue generated (in %) in Taxes on international trade in 1996 to that in 2001?
Your answer should be compact. 1.1. What is the ratio of the Revenue generated (in %) in Taxes on income in 1996 to that in 2002?
Ensure brevity in your answer.  1.61. What is the ratio of the Revenue generated (in %) in Taxes on international trade in 1996 to that in 2002?
Keep it short and to the point. 0.98. What is the ratio of the Revenue generated (in %) in Taxes on goods and services in 1997 to that in 1998?
Your answer should be very brief. 1.16. What is the ratio of the Revenue generated (in %) in Taxes on income in 1997 to that in 1998?
Your answer should be compact. 0.93. What is the ratio of the Revenue generated (in %) of Taxes on international trade in 1997 to that in 1998?
Give a very brief answer. 0.63. What is the ratio of the Revenue generated (in %) in Taxes on goods and services in 1997 to that in 1999?
Your answer should be compact. 1.15. What is the ratio of the Revenue generated (in %) of Taxes on income in 1997 to that in 1999?
Provide a short and direct response. 0.92. What is the ratio of the Revenue generated (in %) in Taxes on international trade in 1997 to that in 1999?
Keep it short and to the point. 1.04. What is the ratio of the Revenue generated (in %) of Taxes on goods and services in 1997 to that in 2001?
Ensure brevity in your answer.  1.11. What is the ratio of the Revenue generated (in %) of Taxes on income in 1997 to that in 2001?
Give a very brief answer. 1.88. What is the ratio of the Revenue generated (in %) in Taxes on international trade in 1997 to that in 2001?
Your answer should be compact. 0.89. What is the ratio of the Revenue generated (in %) of Taxes on goods and services in 1997 to that in 2002?
Your answer should be very brief. 0.92. What is the ratio of the Revenue generated (in %) of Taxes on income in 1997 to that in 2002?
Provide a short and direct response. 1.73. What is the ratio of the Revenue generated (in %) in Taxes on international trade in 1997 to that in 2002?
Offer a very short reply. 0.8. What is the ratio of the Revenue generated (in %) of Taxes on goods and services in 1998 to that in 1999?
Offer a terse response. 0.99. What is the ratio of the Revenue generated (in %) of Taxes on income in 1998 to that in 1999?
Provide a succinct answer. 0.99. What is the ratio of the Revenue generated (in %) of Taxes on international trade in 1998 to that in 1999?
Keep it short and to the point. 1.66. What is the ratio of the Revenue generated (in %) in Taxes on goods and services in 1998 to that in 2001?
Give a very brief answer. 0.96. What is the ratio of the Revenue generated (in %) in Taxes on income in 1998 to that in 2001?
Ensure brevity in your answer.  2.03. What is the ratio of the Revenue generated (in %) of Taxes on international trade in 1998 to that in 2001?
Your answer should be compact. 1.43. What is the ratio of the Revenue generated (in %) of Taxes on goods and services in 1998 to that in 2002?
Your answer should be very brief. 0.8. What is the ratio of the Revenue generated (in %) in Taxes on income in 1998 to that in 2002?
Your response must be concise. 1.87. What is the ratio of the Revenue generated (in %) of Taxes on international trade in 1998 to that in 2002?
Offer a very short reply. 1.28. What is the ratio of the Revenue generated (in %) in Taxes on goods and services in 1999 to that in 2001?
Provide a short and direct response. 0.97. What is the ratio of the Revenue generated (in %) of Taxes on income in 1999 to that in 2001?
Give a very brief answer. 2.05. What is the ratio of the Revenue generated (in %) in Taxes on international trade in 1999 to that in 2001?
Provide a short and direct response. 0.86. What is the ratio of the Revenue generated (in %) in Taxes on goods and services in 1999 to that in 2002?
Keep it short and to the point. 0.8. What is the ratio of the Revenue generated (in %) of Taxes on income in 1999 to that in 2002?
Your response must be concise. 1.88. What is the ratio of the Revenue generated (in %) of Taxes on international trade in 1999 to that in 2002?
Your answer should be very brief. 0.77. What is the ratio of the Revenue generated (in %) of Taxes on goods and services in 2001 to that in 2002?
Ensure brevity in your answer.  0.83. What is the ratio of the Revenue generated (in %) of Taxes on income in 2001 to that in 2002?
Your answer should be compact. 0.92. What is the ratio of the Revenue generated (in %) in Taxes on international trade in 2001 to that in 2002?
Ensure brevity in your answer.  0.9. What is the difference between the highest and the second highest Revenue generated (in %) in Taxes on goods and services?
Keep it short and to the point. 2.04. What is the difference between the highest and the second highest Revenue generated (in %) of Taxes on income?
Keep it short and to the point. 0.62. What is the difference between the highest and the second highest Revenue generated (in %) of Taxes on international trade?
Provide a succinct answer. 0.94. What is the difference between the highest and the lowest Revenue generated (in %) in Taxes on goods and services?
Give a very brief answer. 8.71. What is the difference between the highest and the lowest Revenue generated (in %) in Taxes on income?
Ensure brevity in your answer.  32.88. What is the difference between the highest and the lowest Revenue generated (in %) of Taxes on international trade?
Ensure brevity in your answer.  3.76. 